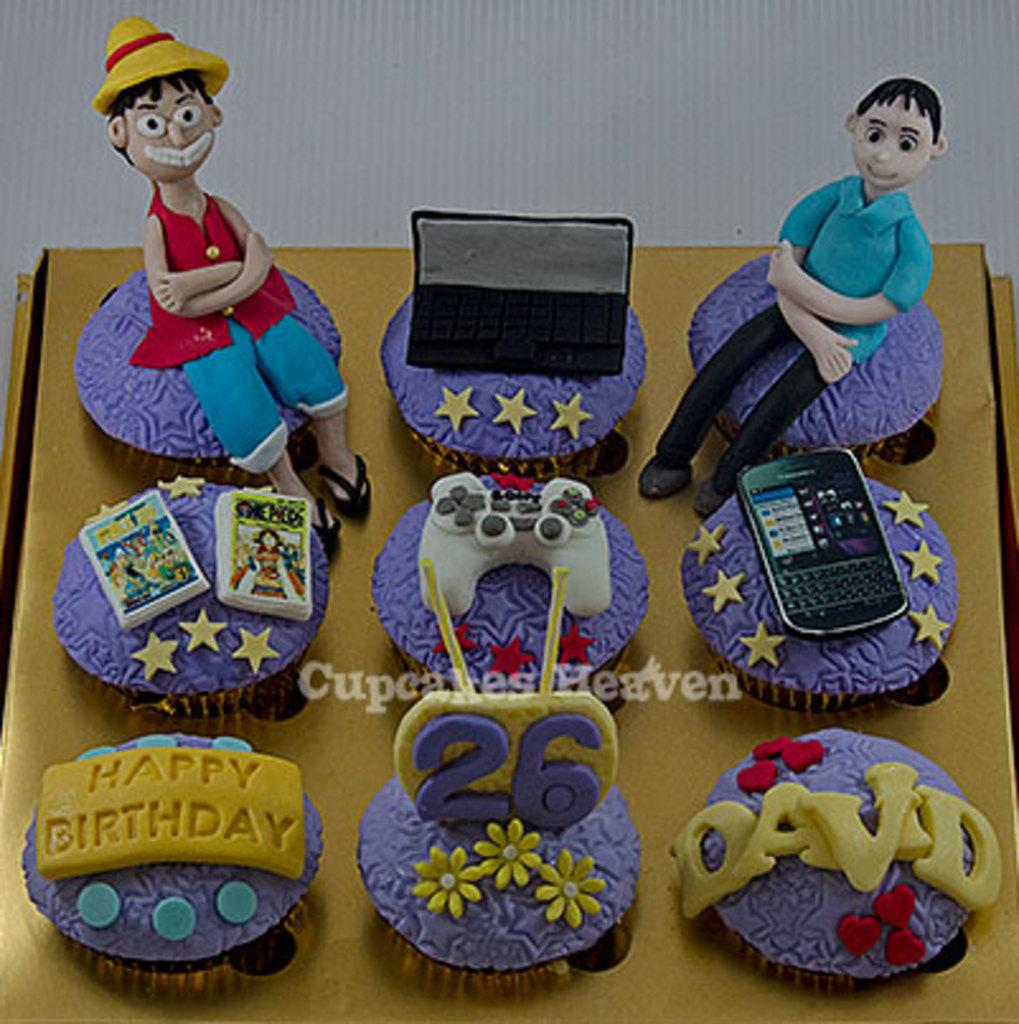What type of food is visible in the image? There are cakes in the image. What electronic device can be seen in the image? There is a phone in the image. What gaming device is present in the image? There is a joystick in the image. What type of computer is visible in the image? There is a laptop in the image. What are the people in the image doing? The people sitting in the image suggest they might be engaged in an activity or conversation. What type of sidewalk can be seen in the image? There is no sidewalk present in the image. What subject is being taught in the image? There is no teaching or learning activity depicted in the image. 